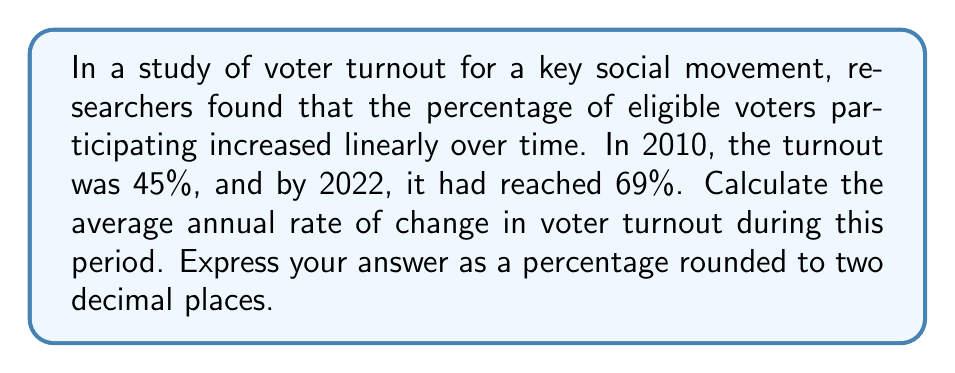Show me your answer to this math problem. To solve this problem, we'll use the formula for the rate of change:

$$ \text{Rate of Change} = \frac{\text{Change in Y}}{\text{Change in X}} $$

1. Identify the given information:
   - Initial year (x₁) = 2010
   - Final year (x₂) = 2022
   - Initial turnout (y₁) = 45%
   - Final turnout (y₂) = 69%

2. Calculate the change in Y (voter turnout):
   $\Delta y = y_2 - y_1 = 69\% - 45\% = 24\%$

3. Calculate the change in X (time in years):
   $\Delta x = x_2 - x_1 = 2022 - 2010 = 12 \text{ years}$

4. Apply the rate of change formula:
   $$ \text{Rate of Change} = \frac{24\%}{12 \text{ years}} = 2\% \text{ per year} $$

5. The question asks for the answer as a percentage rounded to two decimal places, so our final answer is 2.00% per year.
Answer: 2.00% per year 